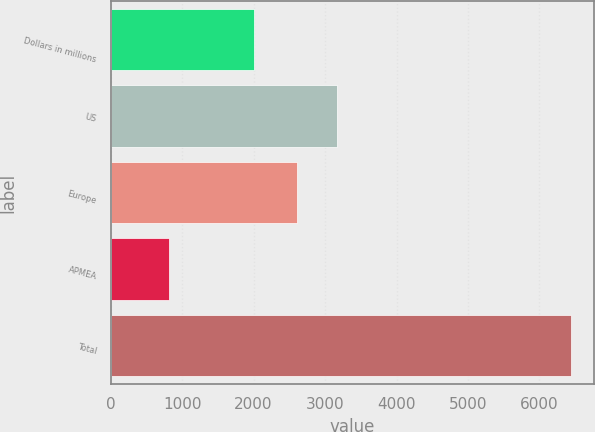Convert chart to OTSL. <chart><loc_0><loc_0><loc_500><loc_500><bar_chart><fcel>Dollars in millions<fcel>US<fcel>Europe<fcel>APMEA<fcel>Total<nl><fcel>2008<fcel>3170.4<fcel>2608<fcel>819<fcel>6443<nl></chart> 